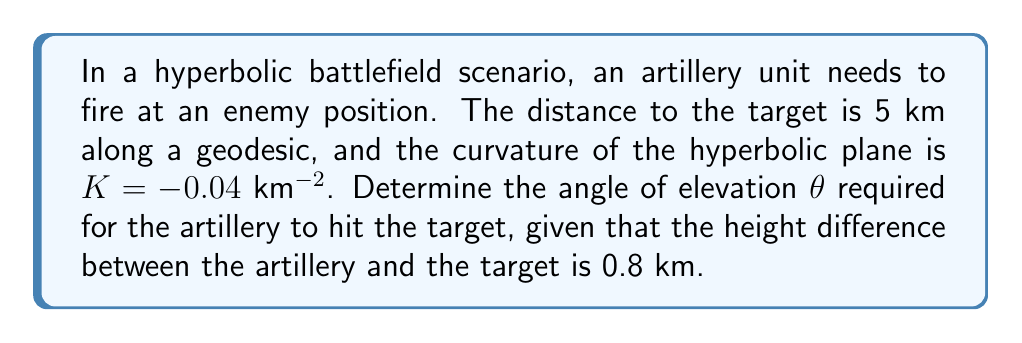Help me with this question. To solve this problem, we'll use the following steps:

1) In hyperbolic geometry, the relationship between the angle of elevation $\theta$, the height difference $h$, and the distance $d$ along a geodesic is given by:

   $$\sinh(\sqrt{-K}h) = \sqrt{-K}d \sin\theta$$

2) We're given:
   $K = -0.04$ km^(-2)
   $d = 5$ km
   $h = 0.8$ km

3) Substitute these values into the equation:

   $$\sinh(0.2 \cdot 0.8) = 0.2 \cdot 5 \sin\theta$$

4) Simplify the left side:
   $$\sinh(0.16) = \sin\theta$$

5) Calculate $\sinh(0.16)$:
   $$\sinh(0.16) \approx 0.1606$$

6) Therefore, our equation becomes:
   $$0.1606 = \sin\theta$$

7) To find $\theta$, we need to take the inverse sine (arcsin) of both sides:
   $$\theta = \arcsin(0.1606)$$

8) Calculate this value:
   $$\theta \approx 9.24^\circ$$

This is the required angle of elevation for the artillery.
Answer: $9.24^\circ$ 